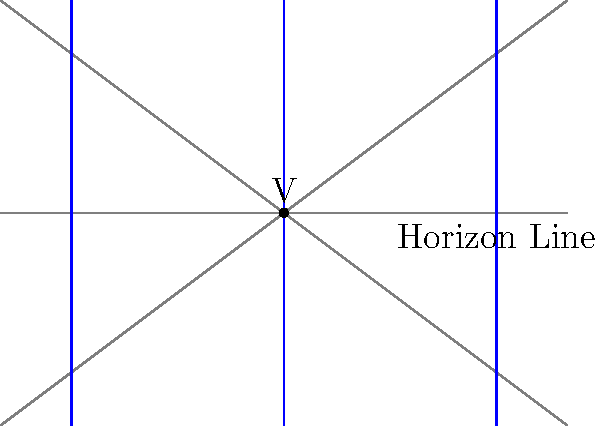In the given perspective diagram of a Renaissance-style interior, where is the vanishing point located in relation to the horizon line? To identify the correct perspective in this Renaissance-style painting diagram:

1. Observe the converging lines: The floor and ceiling lines all converge to a single point.
2. Locate the horizon line: It's the horizontal line running across the center of the image.
3. Find the vanishing point (V): It's where all the converging lines meet.
4. Compare the vanishing point to the horizon line: In this case, the vanishing point is precisely on the horizon line.

This setup demonstrates one-point linear perspective, a technique developed during the Renaissance to create the illusion of depth on a flat surface. The vanishing point on the horizon line is characteristic of this perspective method, which was pioneered by artists like Filippo Brunelleschi and later refined by others such as Leon Battista Alberti.
Answer: On the horizon line 